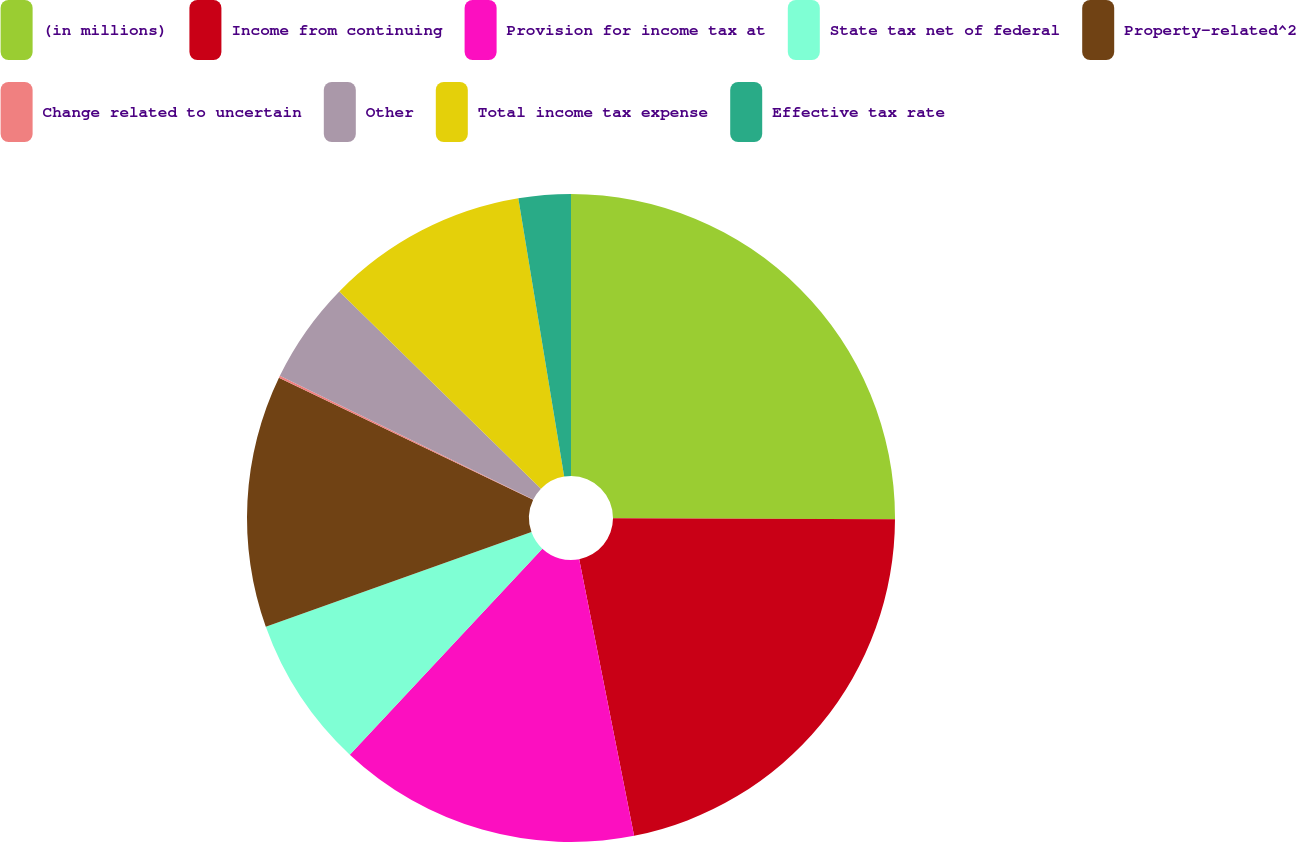<chart> <loc_0><loc_0><loc_500><loc_500><pie_chart><fcel>(in millions)<fcel>Income from continuing<fcel>Provision for income tax at<fcel>State tax net of federal<fcel>Property-related^2<fcel>Change related to uncertain<fcel>Other<fcel>Total income tax expense<fcel>Effective tax rate<nl><fcel>25.06%<fcel>21.82%<fcel>15.08%<fcel>7.59%<fcel>12.58%<fcel>0.1%<fcel>5.09%<fcel>10.08%<fcel>2.6%<nl></chart> 